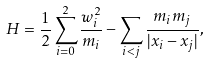<formula> <loc_0><loc_0><loc_500><loc_500>H = { \frac { 1 } { 2 } } \sum _ { i = 0 } ^ { 2 } \frac { w _ { i } ^ { 2 } } { m _ { i } } - \sum _ { i < j } \frac { m _ { i } m _ { j } } { | x _ { i } - x _ { j } | } ,</formula> 